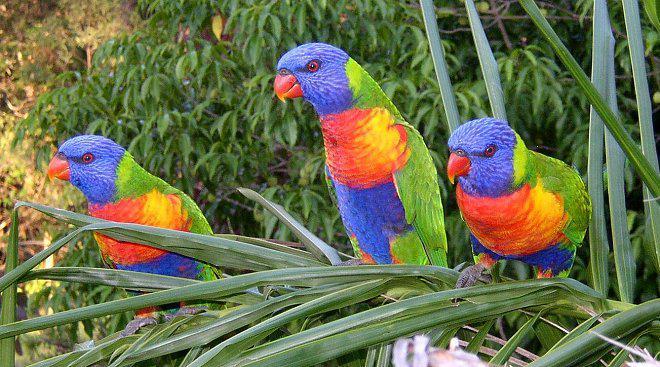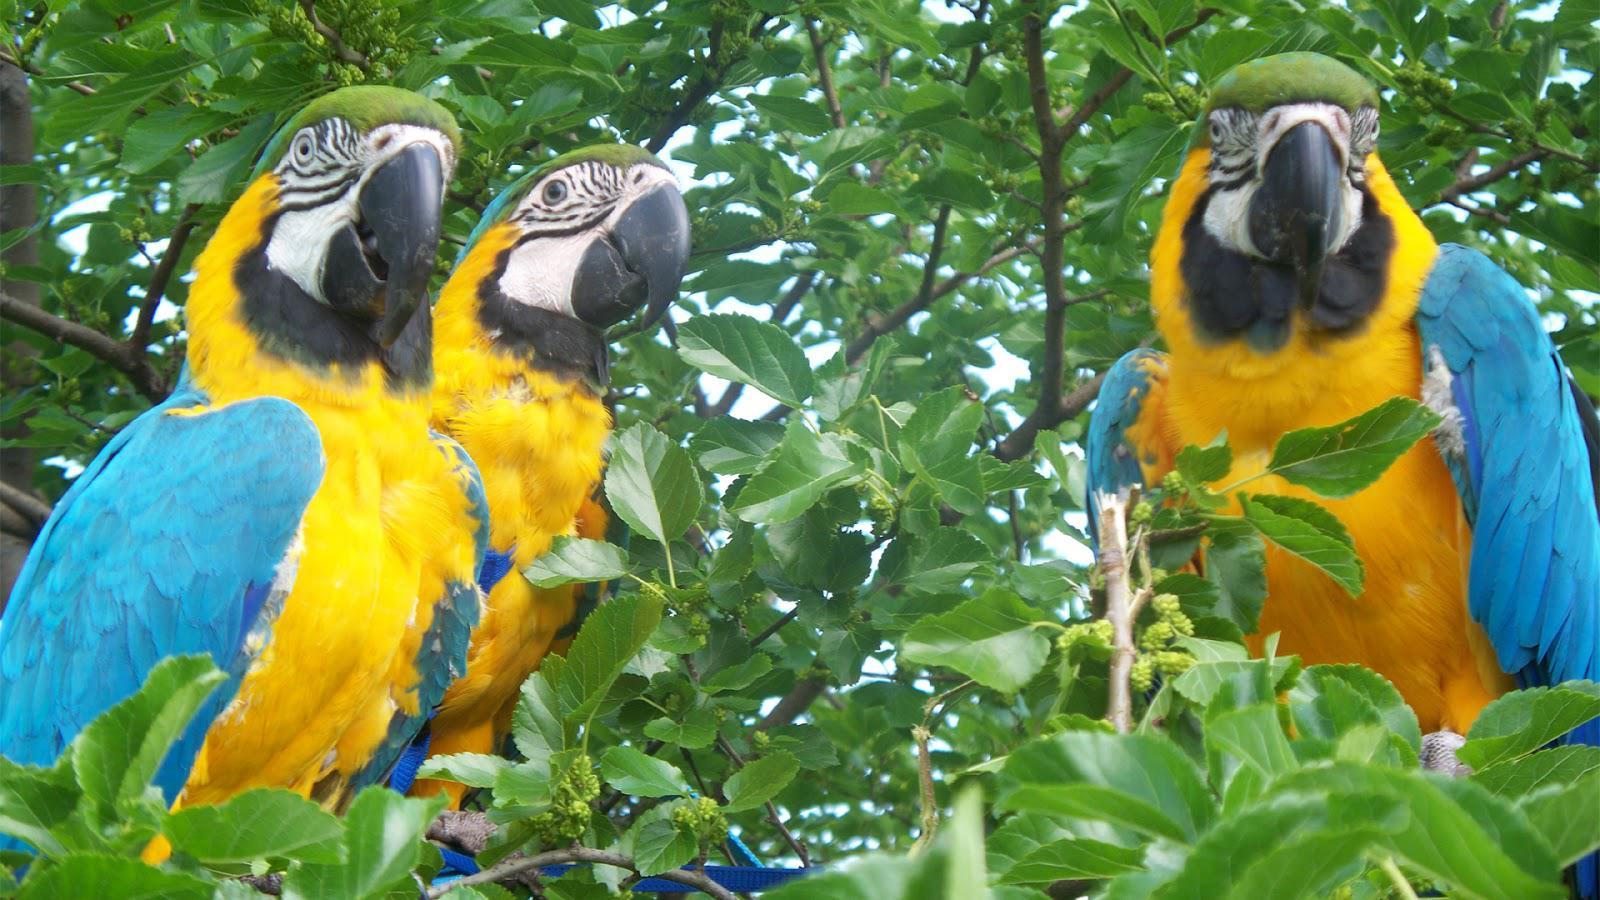The first image is the image on the left, the second image is the image on the right. Analyze the images presented: Is the assertion "There are exactly three birds in the image on the right." valid? Answer yes or no. Yes. 